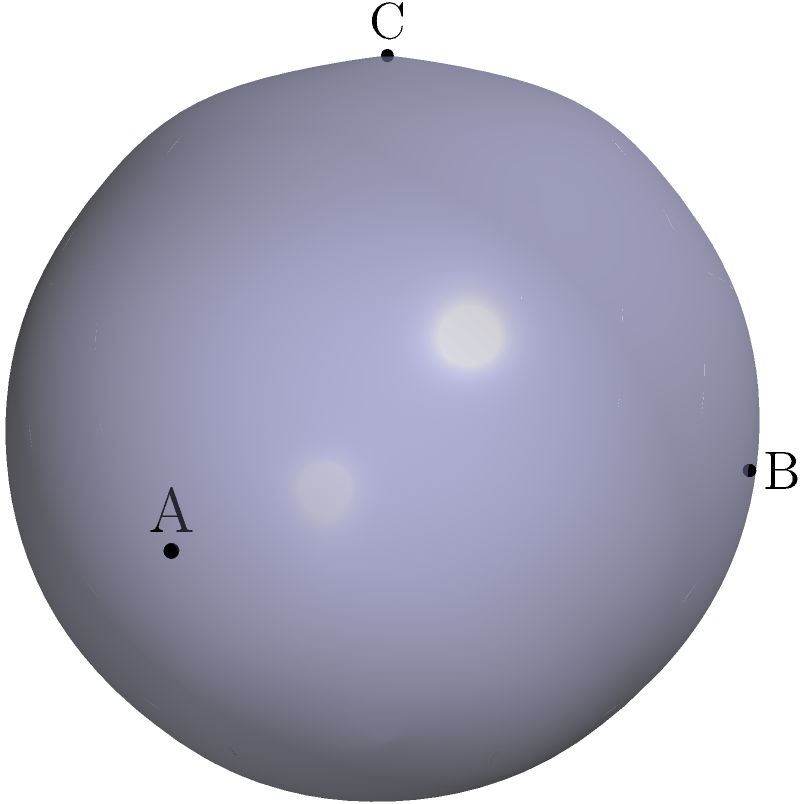On a sphere with radius 2 units, points A, B, and C are located at (2,0,0), (0,2,0), and (0,0,2) respectively. Calculate the total distance along the geodesics (great circle arcs) connecting these three points. Express your answer in terms of $\pi$. To solve this problem, we need to follow these steps:

1) First, recall that the distance along a great circle arc on a sphere of radius $R$ between two points is given by $R\theta$, where $\theta$ is the central angle in radians.

2) The central angle can be calculated using the dot product formula:
   $\cos\theta = \frac{\vec{v_1} \cdot \vec{v_2}}{|\vec{v_1}||\vec{v_2}|}$

3) For each pair of points:

   AB: $\cos\theta_{AB} = \frac{(2,0,0) \cdot (0,2,0)}{2\sqrt{2}} = 0$
       $\theta_{AB} = \arccos(0) = \frac{\pi}{2}$

   BC: $\cos\theta_{BC} = \frac{(0,2,0) \cdot (0,0,2)}{2\sqrt{2}} = 0$
       $\theta_{BC} = \arccos(0) = \frac{\pi}{2}$

   AC: $\cos\theta_{AC} = \frac{(2,0,0) \cdot (0,0,2)}{2\sqrt{2}} = 0$
       $\theta_{AC} = \arccos(0) = \frac{\pi}{2}$

4) The distance for each arc is:
   $d_{AB} = d_{BC} = d_{AC} = R\theta = 2 \cdot \frac{\pi}{2} = \pi$

5) The total distance is the sum of these three arcs:
   $d_{total} = d_{AB} + d_{BC} + d_{AC} = \pi + \pi + \pi = 3\pi$

Therefore, the total distance along the geodesics connecting the three points is $3\pi$ units.
Answer: $3\pi$ units 